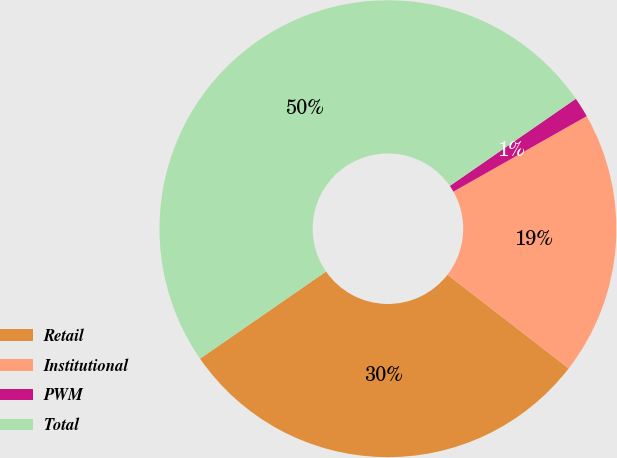<chart> <loc_0><loc_0><loc_500><loc_500><pie_chart><fcel>Retail<fcel>Institutional<fcel>PWM<fcel>Total<nl><fcel>29.9%<fcel>18.67%<fcel>1.43%<fcel>50.0%<nl></chart> 